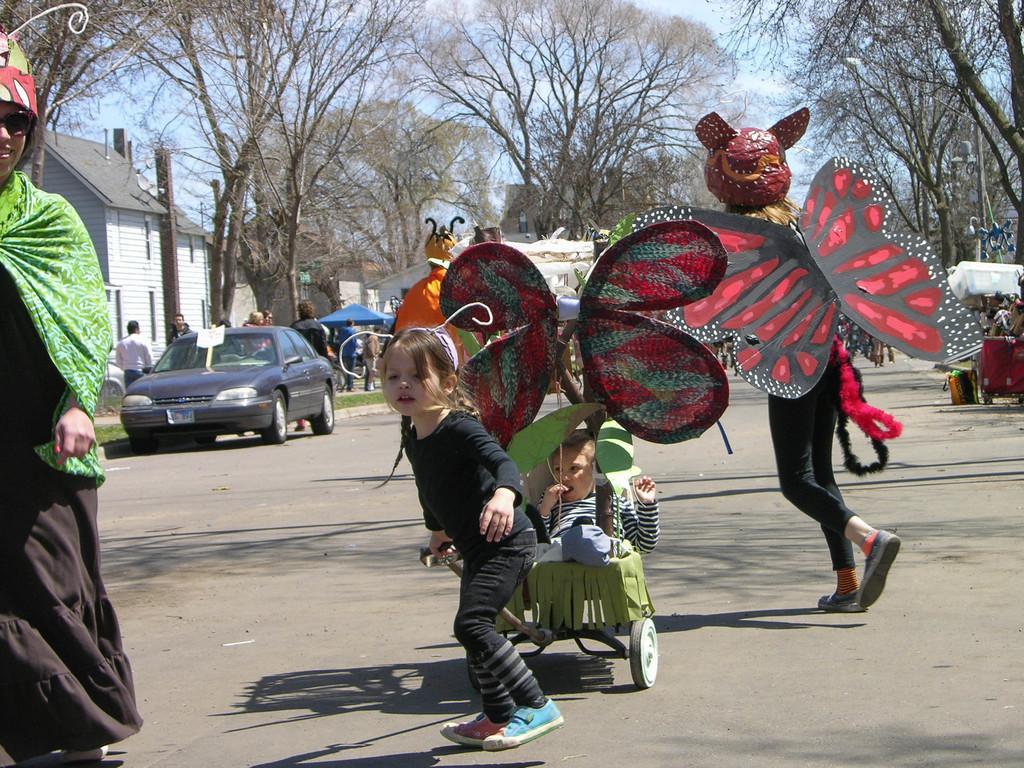How would you summarize this image in a sentence or two? In the image we can see there are people wearing clothes, shoes and they are wearing butterfly wings and caps. We can even see a baby and a girl. There are many buildings, vehicles and trees. Here we can see the grass and the sky. 